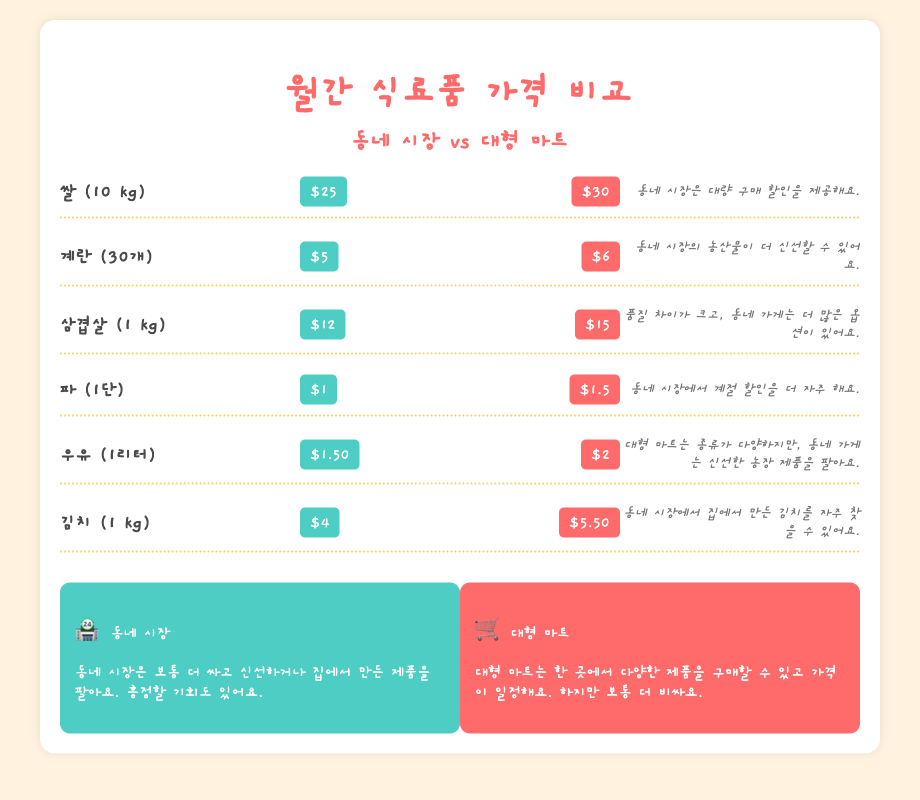What is the price of rice at the local market? The document states that the price of rice (10 kg) at the local market is $25.
Answer: $25 What is the price difference for eggs between the local market and supermarket? The price of eggs (30 pieces) is $5 at the local market and $6 at the supermarket, so the difference is $1.
Answer: $1 Which item is the cheapest at the local market? Among the items listed, the cheapest at the local market is green onions, priced at $1.
Answer: $1 What is one benefit of shopping at the local market mentioned in the document? The document mentions that the local market often has fresher products and provides opportunities for bargaining.
Answer: Fresher products What is the price of kimchi at the supermarket? The document shows that the price of kimchi (1 kg) at the supermarket is $5.50.
Answer: $5.50 What type of products does the local market sell in comparison to the supermarket? The document highlights that the local market sells traditionally homemade or fresher products, while the supermarket offers a variety of products.
Answer: Homemade products How much does 1 liter of milk cost at the supermarket? The price of milk (1 liter) at the supermarket is stated as $2.
Answer: $2 Which shopping option has fixed prices according to the document? The document notes that supermarkets generally have fixed prices compared to local markets.
Answer: Supermarkets What emoji represents the local market in the summary section? The local market is represented by the emoji of a shop, which is 🏪.
Answer: 🏪 